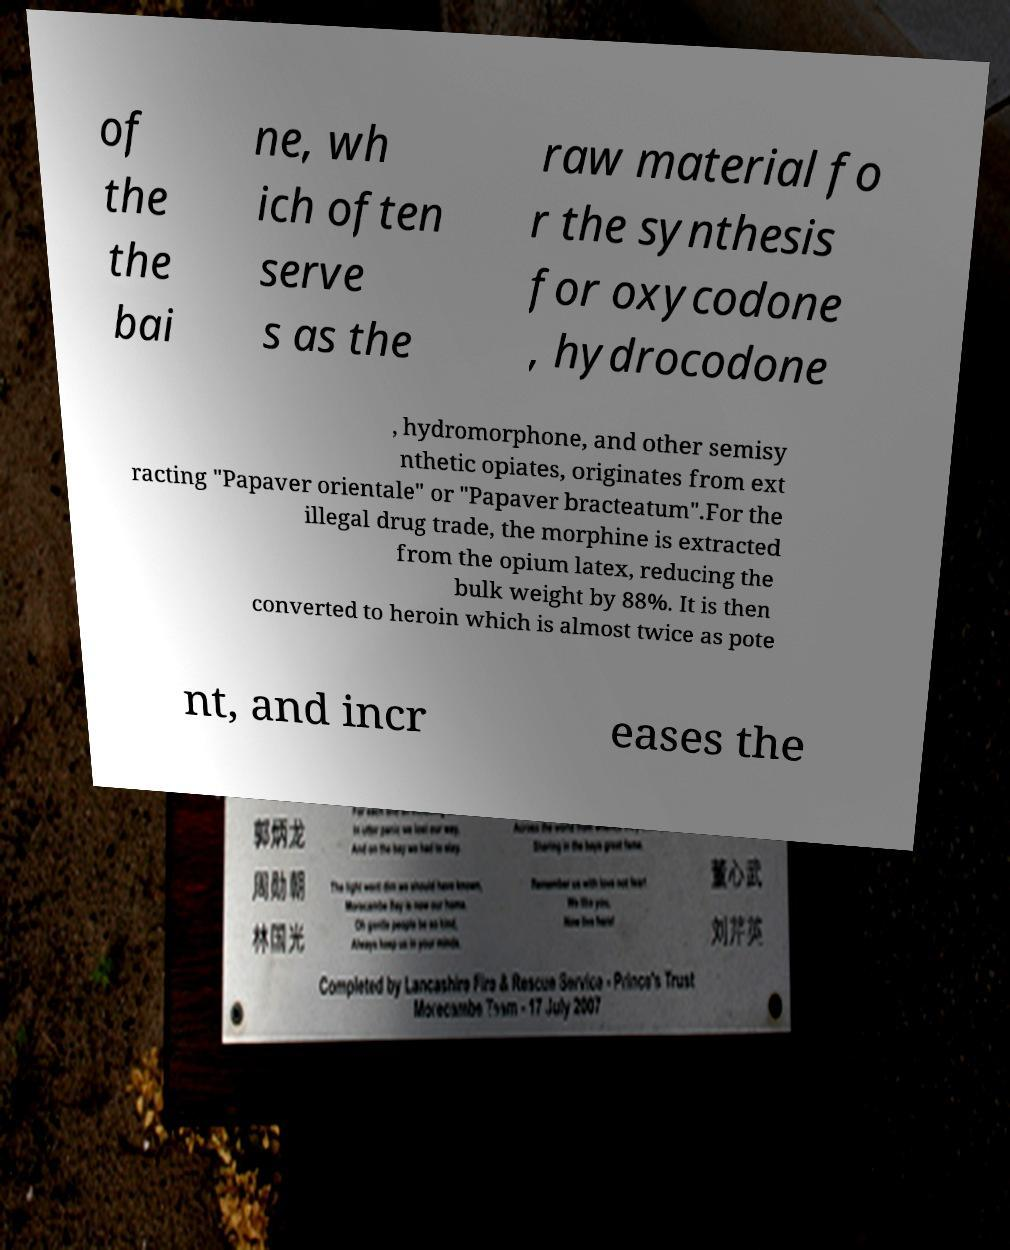Please read and relay the text visible in this image. What does it say? of the the bai ne, wh ich often serve s as the raw material fo r the synthesis for oxycodone , hydrocodone , hydromorphone, and other semisy nthetic opiates, originates from ext racting "Papaver orientale" or "Papaver bracteatum".For the illegal drug trade, the morphine is extracted from the opium latex, reducing the bulk weight by 88%. It is then converted to heroin which is almost twice as pote nt, and incr eases the 